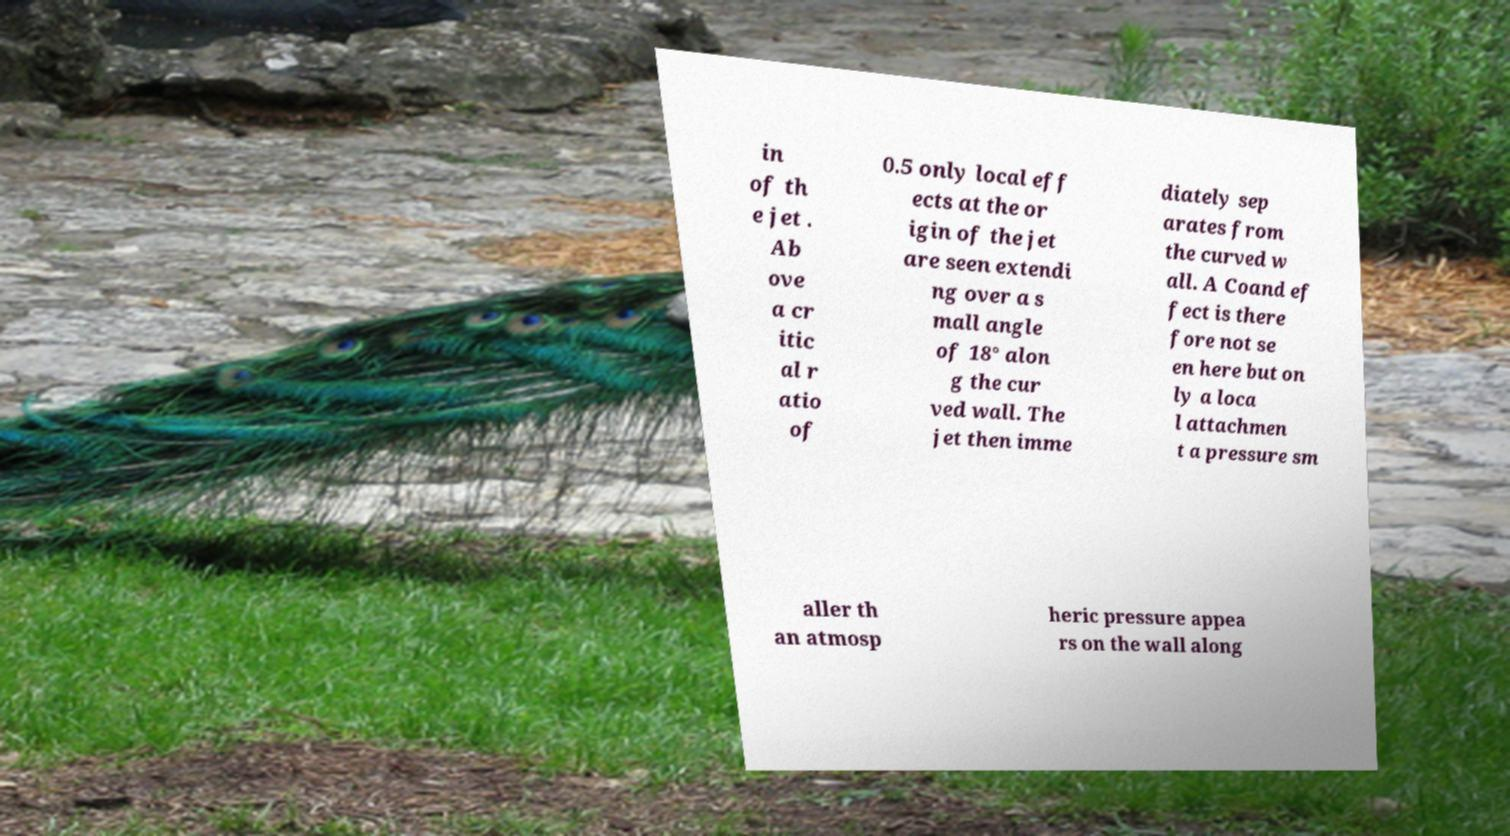There's text embedded in this image that I need extracted. Can you transcribe it verbatim? in of th e jet . Ab ove a cr itic al r atio of 0.5 only local eff ects at the or igin of the jet are seen extendi ng over a s mall angle of 18° alon g the cur ved wall. The jet then imme diately sep arates from the curved w all. A Coand ef fect is there fore not se en here but on ly a loca l attachmen t a pressure sm aller th an atmosp heric pressure appea rs on the wall along 